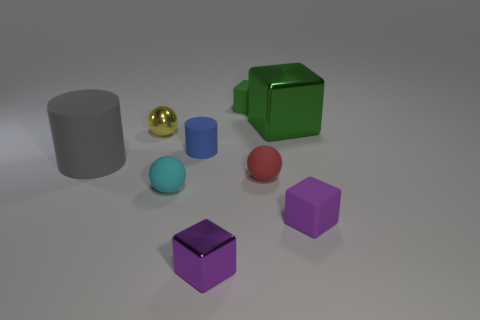Subtract all blue cylinders. Subtract all cyan blocks. How many cylinders are left? 1 Add 1 tiny blue rubber objects. How many objects exist? 10 Subtract all spheres. How many objects are left? 6 Add 6 tiny cyan rubber spheres. How many tiny cyan rubber spheres are left? 7 Add 5 green rubber objects. How many green rubber objects exist? 6 Subtract 0 purple balls. How many objects are left? 9 Subtract all cyan matte spheres. Subtract all gray things. How many objects are left? 7 